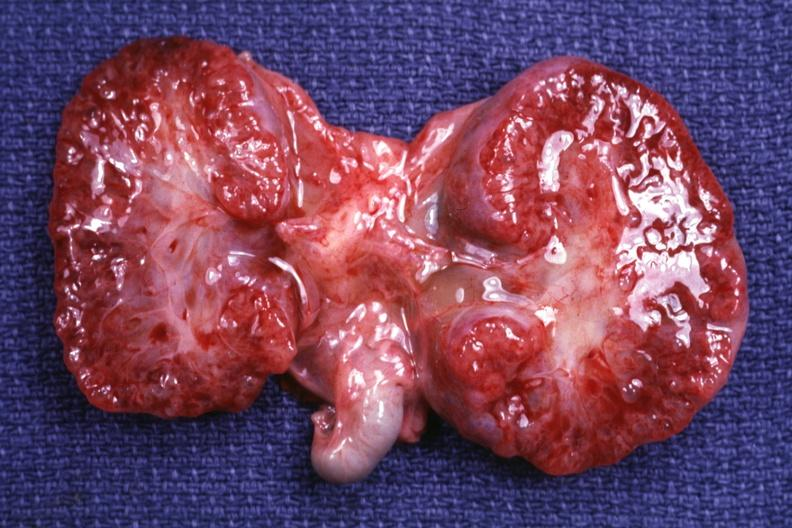does this image show cut surface both kidneys?
Answer the question using a single word or phrase. Yes 